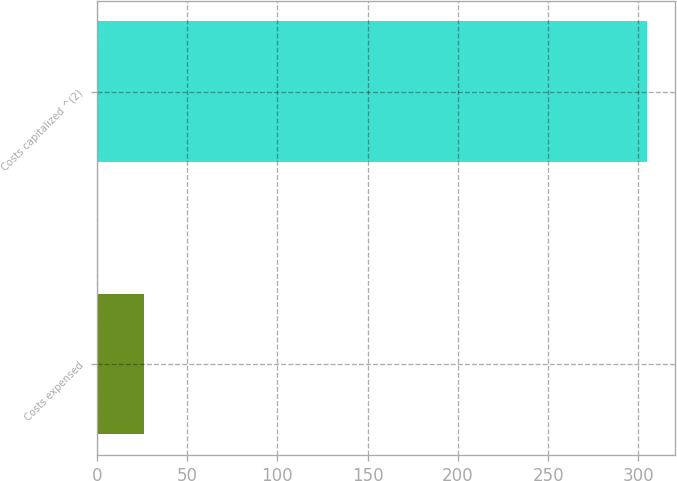<chart> <loc_0><loc_0><loc_500><loc_500><bar_chart><fcel>Costs expensed<fcel>Costs capitalized ^(2)<nl><fcel>26<fcel>305<nl></chart> 